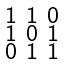<formula> <loc_0><loc_0><loc_500><loc_500>\begin{smallmatrix} 1 & 1 & 0 \\ 1 & 0 & 1 \\ 0 & 1 & 1 \end{smallmatrix}</formula> 